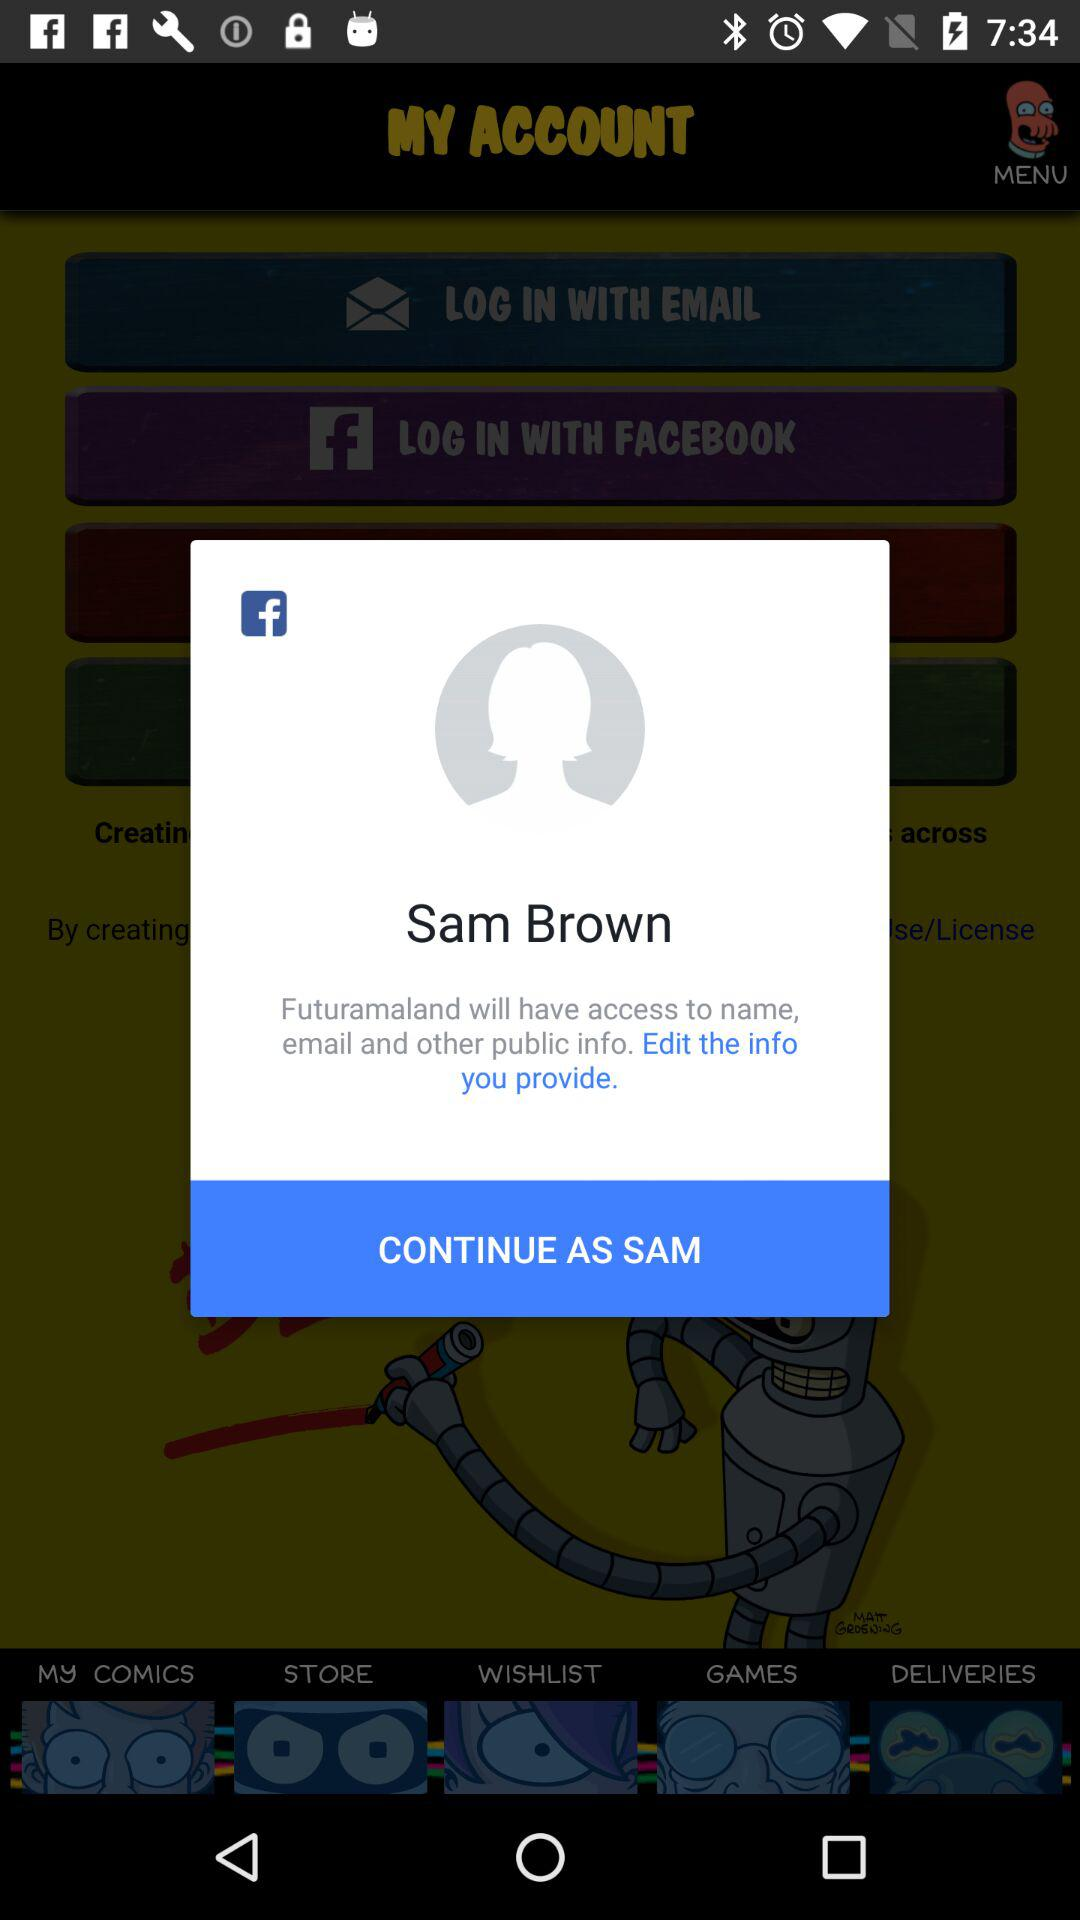Which items are in the wishlist?
When the provided information is insufficient, respond with <no answer>. <no answer> 